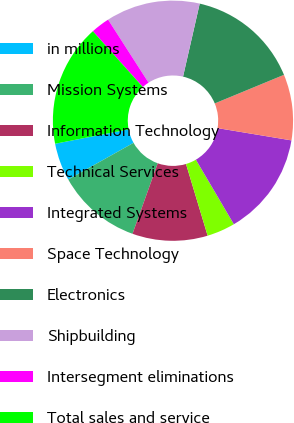Convert chart. <chart><loc_0><loc_0><loc_500><loc_500><pie_chart><fcel>in millions<fcel>Mission Systems<fcel>Information Technology<fcel>Technical Services<fcel>Integrated Systems<fcel>Space Technology<fcel>Electronics<fcel>Shipbuilding<fcel>Intersegment eliminations<fcel>Total sales and service<nl><fcel>5.07%<fcel>11.39%<fcel>10.13%<fcel>3.8%<fcel>13.92%<fcel>8.86%<fcel>15.19%<fcel>12.66%<fcel>2.54%<fcel>16.45%<nl></chart> 